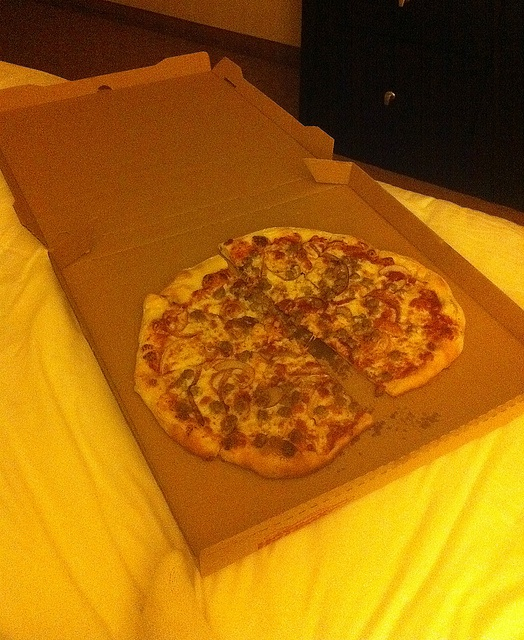Describe the objects in this image and their specific colors. I can see dining table in maroon, orange, and gold tones and pizza in maroon, brown, and orange tones in this image. 